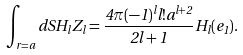<formula> <loc_0><loc_0><loc_500><loc_500>\int _ { r = a } d S H _ { l } Z _ { l } = \frac { 4 \pi ( - 1 ) ^ { l } l ! a ^ { l + 2 } } { 2 l + 1 } H _ { l } ( { e } _ { 1 } ) .</formula> 